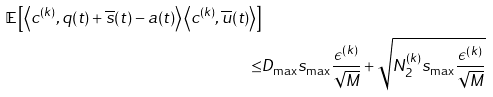<formula> <loc_0><loc_0><loc_500><loc_500>{ \mathbb { E } \left [ \left \langle c ^ { ( k ) } , q ( t ) + \overline { s } ( t ) - a ( t ) \right \rangle \left \langle c ^ { ( k ) } , \overline { u } ( t ) \right \rangle \right ] } \\ \leq & D _ { \max } s _ { \max } \frac { \epsilon ^ { ( k ) } } { \sqrt { M } } + \sqrt { N _ { 2 } ^ { ( k ) } s _ { \max } \frac { \epsilon ^ { ( k ) } } { \sqrt { M } } }</formula> 